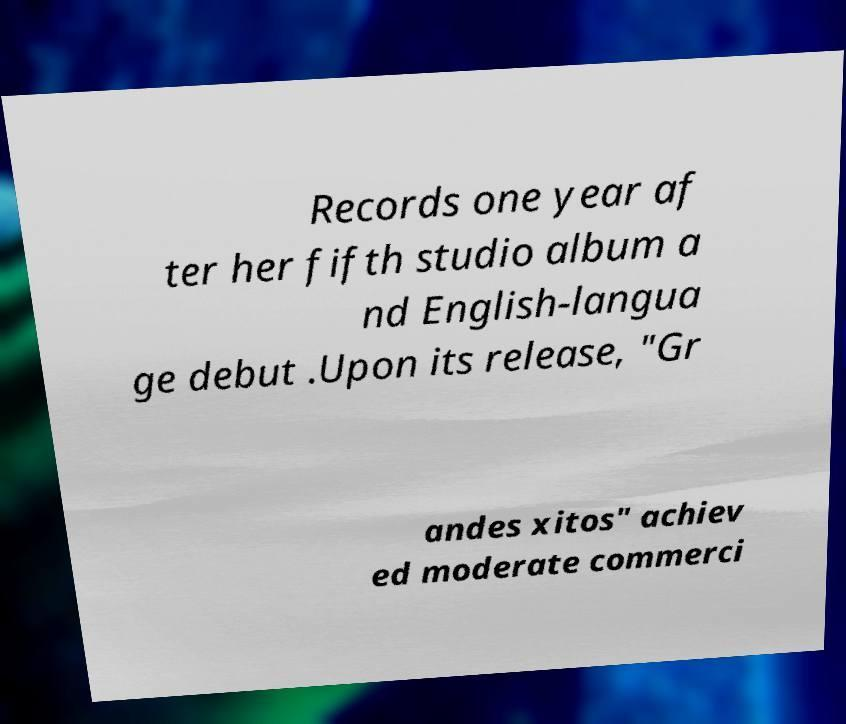Could you assist in decoding the text presented in this image and type it out clearly? Records one year af ter her fifth studio album a nd English-langua ge debut .Upon its release, "Gr andes xitos" achiev ed moderate commerci 